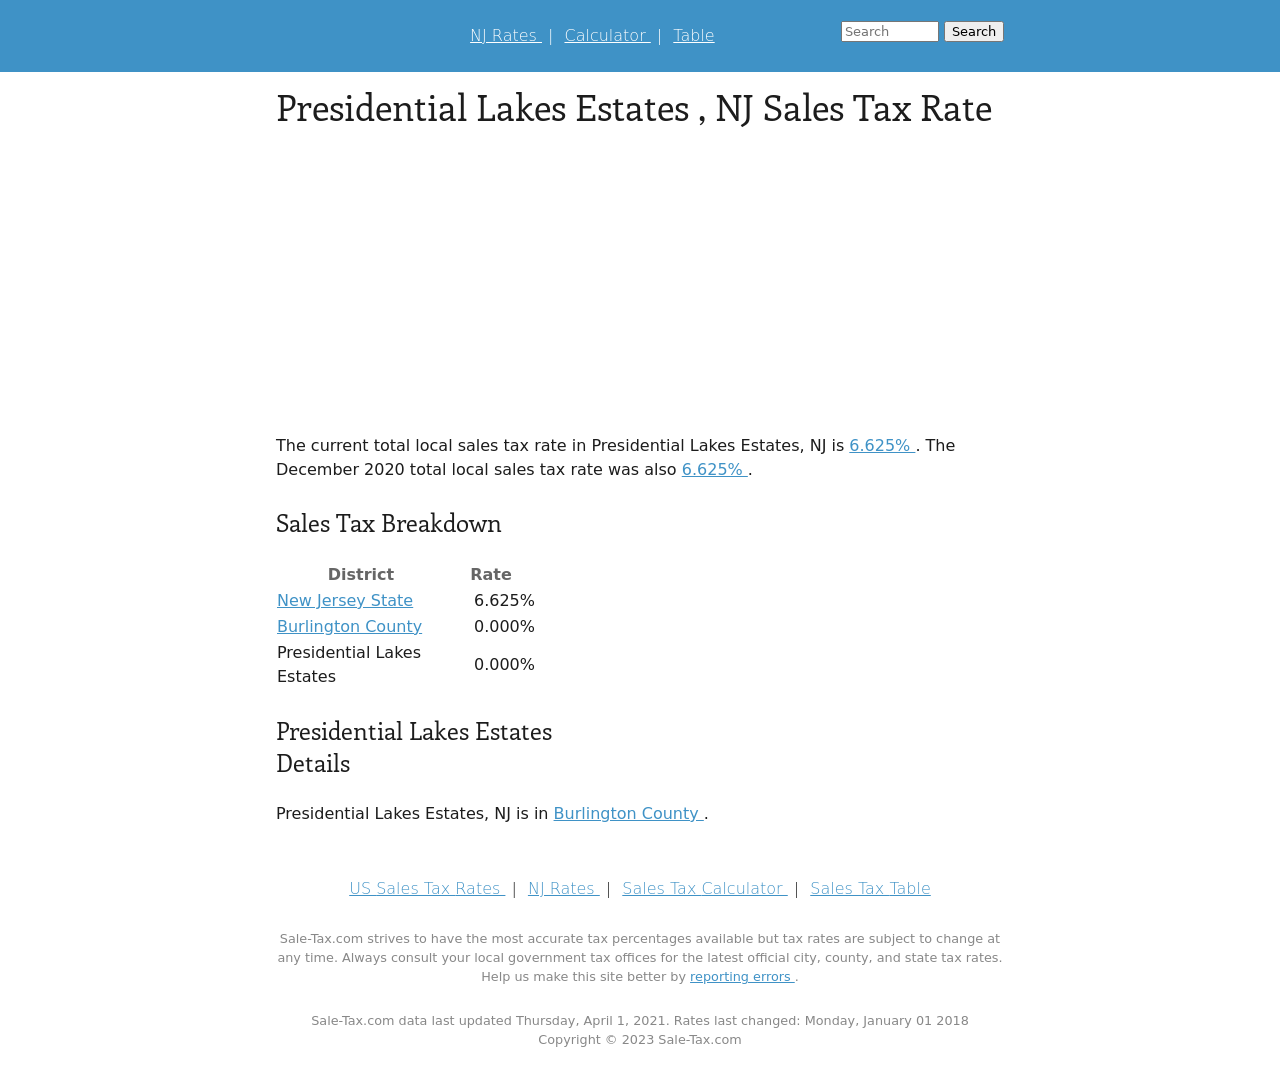Could you guide me through the process of developing this website with HTML? Certainly! To start developing a website like the one in the image, you would begin by structuring your HTML to include elements such as <header> for the top navigation links, and <main> to host the primary content displayed in the image. Here's a simplified version:

<!DOCTYPE html>
<html>
<head>
<title>Presidential Lakes Estates, NJ Sales Tax Rate</title>
</head>
<body>
<header>
<nav>
<a href='#'>NJ Rates</a> | <a href='#'>Calculator</a> | <a href='#'>Table</a>
</nav>
</header>
<main>
<section>
<h1>Presidential Lakes Estates, NJ Sales Tax Rate</h1>
<p>The current total local sales tax rate in Presidential Lakes Estates, NJ is 6.625%.</p>
<table>
<tr><th>District</th><th>Rate</th></tr>
<tr><td>New Jersey State</td><td>6.625%</td></tr>
<tr><td>Burlington County</td><td>0.000%</td></tr>
<tr><td>Presidential Lakes Estates</td><td>0.000%</td></tr>
</table>
</section>
</main>
<footer>
<p>Copyright © 2023 Sale-Tax.com</p>
</footer>
</body>
</html>

This basic structure sets up the elements as seen in the image, then you can enhance and style them using CSS to match the aesthetics of the example provided. 